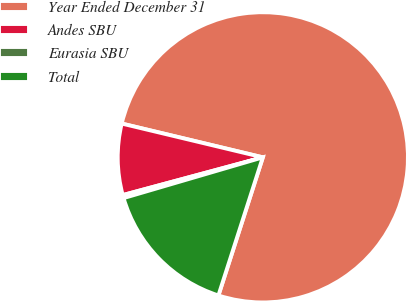Convert chart to OTSL. <chart><loc_0><loc_0><loc_500><loc_500><pie_chart><fcel>Year Ended December 31<fcel>Andes SBU<fcel>Eurasia SBU<fcel>Total<nl><fcel>76.22%<fcel>7.93%<fcel>0.34%<fcel>15.52%<nl></chart> 